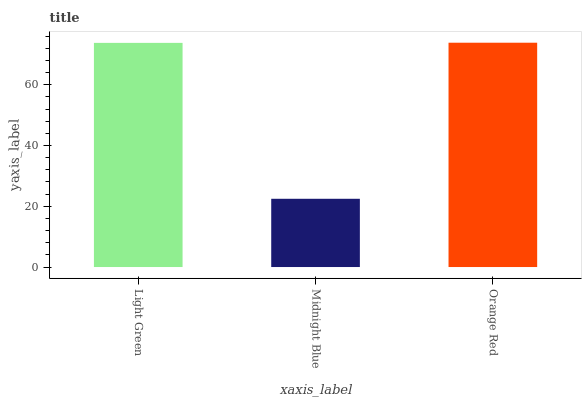Is Midnight Blue the minimum?
Answer yes or no. Yes. Is Orange Red the maximum?
Answer yes or no. Yes. Is Orange Red the minimum?
Answer yes or no. No. Is Midnight Blue the maximum?
Answer yes or no. No. Is Orange Red greater than Midnight Blue?
Answer yes or no. Yes. Is Midnight Blue less than Orange Red?
Answer yes or no. Yes. Is Midnight Blue greater than Orange Red?
Answer yes or no. No. Is Orange Red less than Midnight Blue?
Answer yes or no. No. Is Light Green the high median?
Answer yes or no. Yes. Is Light Green the low median?
Answer yes or no. Yes. Is Midnight Blue the high median?
Answer yes or no. No. Is Orange Red the low median?
Answer yes or no. No. 